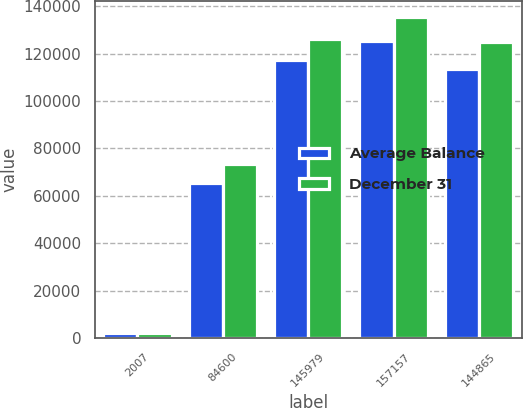<chart> <loc_0><loc_0><loc_500><loc_500><stacked_bar_chart><ecel><fcel>2007<fcel>84600<fcel>145979<fcel>157157<fcel>144865<nl><fcel>Average Balance<fcel>2006<fcel>65535<fcel>117342<fcel>125287<fcel>113568<nl><fcel>December 31<fcel>2007<fcel>73469<fcel>126244<fcel>135319<fcel>124867<nl></chart> 